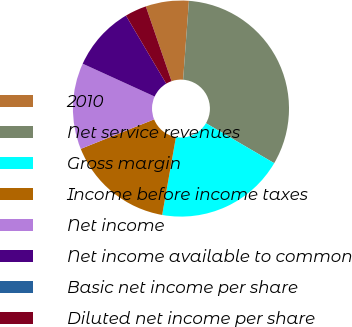<chart> <loc_0><loc_0><loc_500><loc_500><pie_chart><fcel>2010<fcel>Net service revenues<fcel>Gross margin<fcel>Income before income taxes<fcel>Net income<fcel>Net income available to common<fcel>Basic net income per share<fcel>Diluted net income per share<nl><fcel>6.45%<fcel>32.26%<fcel>19.35%<fcel>16.13%<fcel>12.9%<fcel>9.68%<fcel>0.0%<fcel>3.23%<nl></chart> 